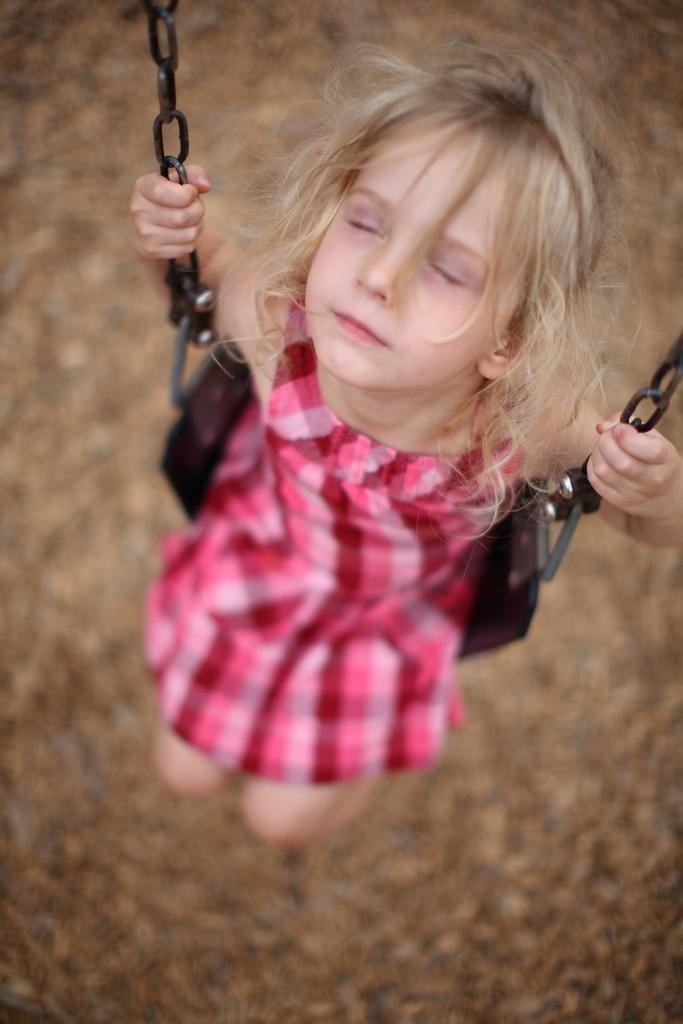What is the main subject of the image? The main subject of the image is a baby. What is the baby wearing? The baby is wearing a red gown. What is the baby doing in the image? The baby is sitting on a swing. How many cows are visible in the image? There are no cows present in the image. What type of advertisement is being displayed on the swing? There is no advertisement present in the image; it is a baby sitting on a swing. 